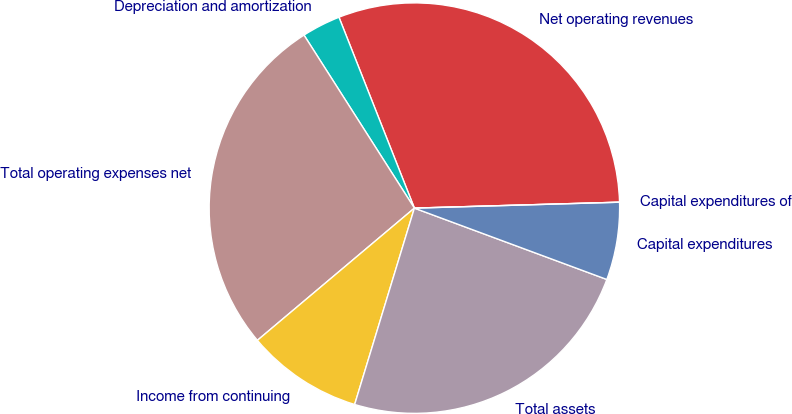Convert chart. <chart><loc_0><loc_0><loc_500><loc_500><pie_chart><fcel>Net operating revenues<fcel>Depreciation and amortization<fcel>Total operating expenses net<fcel>Income from continuing<fcel>Total assets<fcel>Capital expenditures<fcel>Capital expenditures of<nl><fcel>30.53%<fcel>3.05%<fcel>27.1%<fcel>9.16%<fcel>24.05%<fcel>6.11%<fcel>0.0%<nl></chart> 